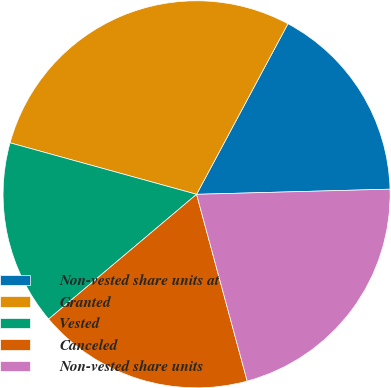<chart> <loc_0><loc_0><loc_500><loc_500><pie_chart><fcel>Non-vested share units at<fcel>Granted<fcel>Vested<fcel>Canceled<fcel>Non-vested share units<nl><fcel>16.75%<fcel>28.54%<fcel>15.44%<fcel>18.06%<fcel>21.21%<nl></chart> 